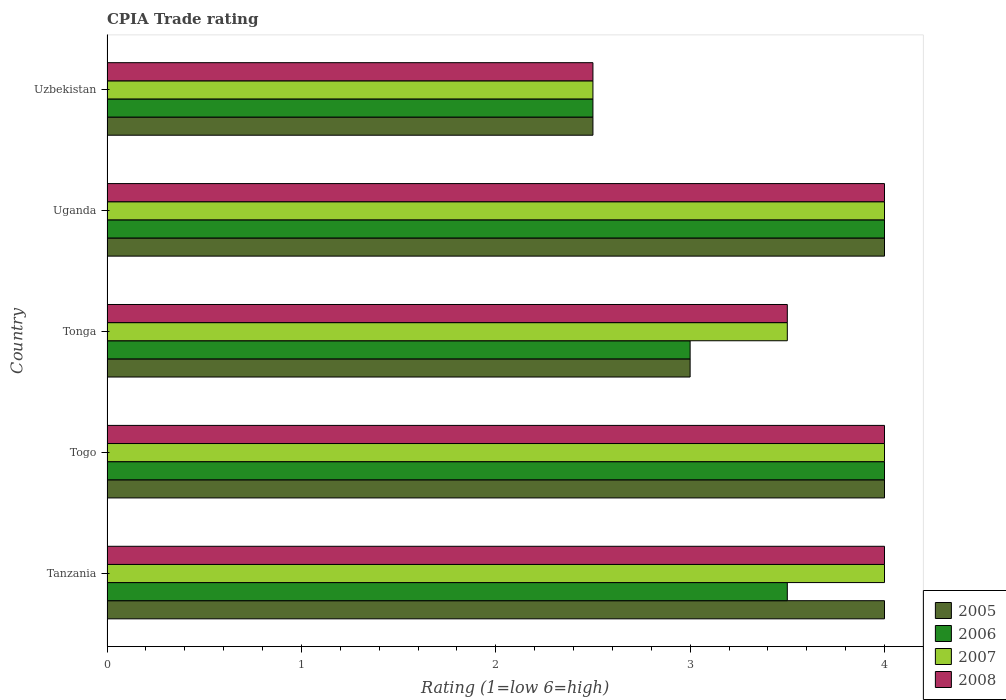How many different coloured bars are there?
Make the answer very short. 4. How many bars are there on the 3rd tick from the bottom?
Your response must be concise. 4. What is the label of the 4th group of bars from the top?
Provide a short and direct response. Togo. In how many cases, is the number of bars for a given country not equal to the number of legend labels?
Offer a terse response. 0. What is the CPIA rating in 2006 in Uganda?
Provide a succinct answer. 4. In which country was the CPIA rating in 2006 maximum?
Your answer should be compact. Togo. In which country was the CPIA rating in 2008 minimum?
Offer a terse response. Uzbekistan. What is the total CPIA rating in 2008 in the graph?
Keep it short and to the point. 18. What is the difference between the CPIA rating in 2005 in Tanzania and that in Uzbekistan?
Give a very brief answer. 1.5. What is the difference between the CPIA rating in 2006 in Uzbekistan and the CPIA rating in 2008 in Tonga?
Provide a short and direct response. -1. What is the average CPIA rating in 2005 per country?
Your answer should be very brief. 3.5. What is the difference between the CPIA rating in 2008 and CPIA rating in 2005 in Tonga?
Provide a succinct answer. 0.5. In how many countries, is the CPIA rating in 2008 greater than the average CPIA rating in 2008 taken over all countries?
Offer a very short reply. 3. Is it the case that in every country, the sum of the CPIA rating in 2006 and CPIA rating in 2008 is greater than the sum of CPIA rating in 2007 and CPIA rating in 2005?
Provide a succinct answer. No. Are all the bars in the graph horizontal?
Keep it short and to the point. Yes. How many countries are there in the graph?
Your answer should be compact. 5. Are the values on the major ticks of X-axis written in scientific E-notation?
Ensure brevity in your answer.  No. Does the graph contain any zero values?
Offer a terse response. No. How many legend labels are there?
Offer a terse response. 4. How are the legend labels stacked?
Your answer should be very brief. Vertical. What is the title of the graph?
Keep it short and to the point. CPIA Trade rating. Does "2013" appear as one of the legend labels in the graph?
Provide a short and direct response. No. What is the label or title of the X-axis?
Your answer should be very brief. Rating (1=low 6=high). What is the Rating (1=low 6=high) in 2005 in Tanzania?
Provide a succinct answer. 4. What is the Rating (1=low 6=high) in 2006 in Tanzania?
Ensure brevity in your answer.  3.5. What is the Rating (1=low 6=high) of 2008 in Togo?
Make the answer very short. 4. What is the Rating (1=low 6=high) in 2005 in Tonga?
Your answer should be very brief. 3. What is the Rating (1=low 6=high) in 2006 in Tonga?
Make the answer very short. 3. What is the Rating (1=low 6=high) in 2007 in Tonga?
Give a very brief answer. 3.5. What is the Rating (1=low 6=high) in 2008 in Tonga?
Provide a short and direct response. 3.5. What is the Rating (1=low 6=high) of 2007 in Uganda?
Make the answer very short. 4. What is the Rating (1=low 6=high) of 2008 in Uganda?
Keep it short and to the point. 4. What is the Rating (1=low 6=high) in 2007 in Uzbekistan?
Ensure brevity in your answer.  2.5. Across all countries, what is the maximum Rating (1=low 6=high) in 2007?
Your answer should be compact. 4. Across all countries, what is the minimum Rating (1=low 6=high) in 2005?
Offer a very short reply. 2.5. Across all countries, what is the minimum Rating (1=low 6=high) in 2007?
Offer a very short reply. 2.5. What is the total Rating (1=low 6=high) in 2006 in the graph?
Your response must be concise. 17. What is the total Rating (1=low 6=high) in 2007 in the graph?
Give a very brief answer. 18. What is the total Rating (1=low 6=high) of 2008 in the graph?
Offer a very short reply. 18. What is the difference between the Rating (1=low 6=high) of 2005 in Tanzania and that in Togo?
Your answer should be compact. 0. What is the difference between the Rating (1=low 6=high) of 2006 in Tanzania and that in Togo?
Make the answer very short. -0.5. What is the difference between the Rating (1=low 6=high) in 2006 in Tanzania and that in Tonga?
Give a very brief answer. 0.5. What is the difference between the Rating (1=low 6=high) in 2005 in Tanzania and that in Uganda?
Offer a terse response. 0. What is the difference between the Rating (1=low 6=high) of 2006 in Tanzania and that in Uganda?
Provide a succinct answer. -0.5. What is the difference between the Rating (1=low 6=high) in 2008 in Tanzania and that in Uganda?
Your response must be concise. 0. What is the difference between the Rating (1=low 6=high) in 2005 in Tanzania and that in Uzbekistan?
Ensure brevity in your answer.  1.5. What is the difference between the Rating (1=low 6=high) in 2007 in Tanzania and that in Uzbekistan?
Provide a succinct answer. 1.5. What is the difference between the Rating (1=low 6=high) of 2006 in Togo and that in Tonga?
Provide a short and direct response. 1. What is the difference between the Rating (1=low 6=high) of 2007 in Togo and that in Tonga?
Provide a short and direct response. 0.5. What is the difference between the Rating (1=low 6=high) of 2008 in Togo and that in Tonga?
Offer a terse response. 0.5. What is the difference between the Rating (1=low 6=high) of 2007 in Togo and that in Uganda?
Your response must be concise. 0. What is the difference between the Rating (1=low 6=high) of 2008 in Togo and that in Uganda?
Provide a succinct answer. 0. What is the difference between the Rating (1=low 6=high) in 2007 in Togo and that in Uzbekistan?
Your answer should be compact. 1.5. What is the difference between the Rating (1=low 6=high) of 2008 in Togo and that in Uzbekistan?
Keep it short and to the point. 1.5. What is the difference between the Rating (1=low 6=high) in 2006 in Tonga and that in Uganda?
Give a very brief answer. -1. What is the difference between the Rating (1=low 6=high) of 2007 in Tonga and that in Uganda?
Provide a succinct answer. -0.5. What is the difference between the Rating (1=low 6=high) of 2008 in Tonga and that in Uganda?
Keep it short and to the point. -0.5. What is the difference between the Rating (1=low 6=high) of 2005 in Tonga and that in Uzbekistan?
Give a very brief answer. 0.5. What is the difference between the Rating (1=low 6=high) of 2007 in Tonga and that in Uzbekistan?
Your response must be concise. 1. What is the difference between the Rating (1=low 6=high) of 2005 in Uganda and that in Uzbekistan?
Provide a short and direct response. 1.5. What is the difference between the Rating (1=low 6=high) of 2006 in Uganda and that in Uzbekistan?
Keep it short and to the point. 1.5. What is the difference between the Rating (1=low 6=high) in 2007 in Uganda and that in Uzbekistan?
Your response must be concise. 1.5. What is the difference between the Rating (1=low 6=high) of 2005 in Tanzania and the Rating (1=low 6=high) of 2006 in Togo?
Offer a very short reply. 0. What is the difference between the Rating (1=low 6=high) of 2005 in Tanzania and the Rating (1=low 6=high) of 2008 in Togo?
Your response must be concise. 0. What is the difference between the Rating (1=low 6=high) in 2006 in Tanzania and the Rating (1=low 6=high) in 2007 in Togo?
Provide a succinct answer. -0.5. What is the difference between the Rating (1=low 6=high) of 2005 in Tanzania and the Rating (1=low 6=high) of 2006 in Tonga?
Give a very brief answer. 1. What is the difference between the Rating (1=low 6=high) of 2005 in Tanzania and the Rating (1=low 6=high) of 2007 in Tonga?
Your answer should be very brief. 0.5. What is the difference between the Rating (1=low 6=high) of 2005 in Tanzania and the Rating (1=low 6=high) of 2008 in Tonga?
Your answer should be compact. 0.5. What is the difference between the Rating (1=low 6=high) of 2006 in Tanzania and the Rating (1=low 6=high) of 2007 in Tonga?
Your response must be concise. 0. What is the difference between the Rating (1=low 6=high) of 2006 in Tanzania and the Rating (1=low 6=high) of 2008 in Tonga?
Offer a very short reply. 0. What is the difference between the Rating (1=low 6=high) of 2007 in Tanzania and the Rating (1=low 6=high) of 2008 in Tonga?
Your response must be concise. 0.5. What is the difference between the Rating (1=low 6=high) in 2005 in Tanzania and the Rating (1=low 6=high) in 2006 in Uganda?
Give a very brief answer. 0. What is the difference between the Rating (1=low 6=high) of 2005 in Tanzania and the Rating (1=low 6=high) of 2008 in Uganda?
Ensure brevity in your answer.  0. What is the difference between the Rating (1=low 6=high) of 2006 in Tanzania and the Rating (1=low 6=high) of 2007 in Uganda?
Ensure brevity in your answer.  -0.5. What is the difference between the Rating (1=low 6=high) of 2006 in Tanzania and the Rating (1=low 6=high) of 2008 in Uganda?
Make the answer very short. -0.5. What is the difference between the Rating (1=low 6=high) in 2007 in Tanzania and the Rating (1=low 6=high) in 2008 in Uganda?
Keep it short and to the point. 0. What is the difference between the Rating (1=low 6=high) in 2007 in Tanzania and the Rating (1=low 6=high) in 2008 in Uzbekistan?
Your response must be concise. 1.5. What is the difference between the Rating (1=low 6=high) of 2005 in Togo and the Rating (1=low 6=high) of 2008 in Tonga?
Ensure brevity in your answer.  0.5. What is the difference between the Rating (1=low 6=high) in 2006 in Togo and the Rating (1=low 6=high) in 2007 in Tonga?
Your answer should be compact. 0.5. What is the difference between the Rating (1=low 6=high) of 2007 in Togo and the Rating (1=low 6=high) of 2008 in Tonga?
Make the answer very short. 0.5. What is the difference between the Rating (1=low 6=high) of 2005 in Togo and the Rating (1=low 6=high) of 2006 in Uzbekistan?
Ensure brevity in your answer.  1.5. What is the difference between the Rating (1=low 6=high) in 2005 in Togo and the Rating (1=low 6=high) in 2008 in Uzbekistan?
Your answer should be very brief. 1.5. What is the difference between the Rating (1=low 6=high) of 2006 in Togo and the Rating (1=low 6=high) of 2007 in Uzbekistan?
Your answer should be very brief. 1.5. What is the difference between the Rating (1=low 6=high) of 2007 in Togo and the Rating (1=low 6=high) of 2008 in Uzbekistan?
Keep it short and to the point. 1.5. What is the difference between the Rating (1=low 6=high) in 2005 in Tonga and the Rating (1=low 6=high) in 2006 in Uganda?
Offer a terse response. -1. What is the difference between the Rating (1=low 6=high) of 2005 in Tonga and the Rating (1=low 6=high) of 2008 in Uganda?
Provide a succinct answer. -1. What is the difference between the Rating (1=low 6=high) of 2005 in Tonga and the Rating (1=low 6=high) of 2007 in Uzbekistan?
Keep it short and to the point. 0.5. What is the difference between the Rating (1=low 6=high) in 2005 in Tonga and the Rating (1=low 6=high) in 2008 in Uzbekistan?
Make the answer very short. 0.5. What is the difference between the Rating (1=low 6=high) in 2006 in Tonga and the Rating (1=low 6=high) in 2007 in Uzbekistan?
Make the answer very short. 0.5. What is the difference between the Rating (1=low 6=high) in 2006 in Tonga and the Rating (1=low 6=high) in 2008 in Uzbekistan?
Offer a very short reply. 0.5. What is the difference between the Rating (1=low 6=high) of 2007 in Tonga and the Rating (1=low 6=high) of 2008 in Uzbekistan?
Ensure brevity in your answer.  1. What is the difference between the Rating (1=low 6=high) of 2005 in Uganda and the Rating (1=low 6=high) of 2008 in Uzbekistan?
Ensure brevity in your answer.  1.5. What is the difference between the Rating (1=low 6=high) in 2006 in Uganda and the Rating (1=low 6=high) in 2007 in Uzbekistan?
Offer a terse response. 1.5. What is the difference between the Rating (1=low 6=high) in 2006 in Uganda and the Rating (1=low 6=high) in 2008 in Uzbekistan?
Offer a terse response. 1.5. What is the average Rating (1=low 6=high) in 2005 per country?
Make the answer very short. 3.5. What is the average Rating (1=low 6=high) of 2007 per country?
Provide a short and direct response. 3.6. What is the average Rating (1=low 6=high) of 2008 per country?
Make the answer very short. 3.6. What is the difference between the Rating (1=low 6=high) in 2005 and Rating (1=low 6=high) in 2007 in Tanzania?
Ensure brevity in your answer.  0. What is the difference between the Rating (1=low 6=high) of 2005 and Rating (1=low 6=high) of 2008 in Tanzania?
Ensure brevity in your answer.  0. What is the difference between the Rating (1=low 6=high) of 2006 and Rating (1=low 6=high) of 2008 in Tanzania?
Give a very brief answer. -0.5. What is the difference between the Rating (1=low 6=high) in 2007 and Rating (1=low 6=high) in 2008 in Tanzania?
Offer a terse response. 0. What is the difference between the Rating (1=low 6=high) of 2005 and Rating (1=low 6=high) of 2006 in Togo?
Make the answer very short. 0. What is the difference between the Rating (1=low 6=high) of 2005 and Rating (1=low 6=high) of 2007 in Togo?
Provide a succinct answer. 0. What is the difference between the Rating (1=low 6=high) of 2005 and Rating (1=low 6=high) of 2008 in Togo?
Provide a short and direct response. 0. What is the difference between the Rating (1=low 6=high) in 2006 and Rating (1=low 6=high) in 2007 in Togo?
Provide a short and direct response. 0. What is the difference between the Rating (1=low 6=high) of 2006 and Rating (1=low 6=high) of 2008 in Togo?
Give a very brief answer. 0. What is the difference between the Rating (1=low 6=high) of 2007 and Rating (1=low 6=high) of 2008 in Togo?
Your response must be concise. 0. What is the difference between the Rating (1=low 6=high) of 2005 and Rating (1=low 6=high) of 2006 in Tonga?
Your answer should be very brief. 0. What is the difference between the Rating (1=low 6=high) of 2005 and Rating (1=low 6=high) of 2007 in Tonga?
Offer a terse response. -0.5. What is the difference between the Rating (1=low 6=high) in 2006 and Rating (1=low 6=high) in 2008 in Tonga?
Offer a terse response. -0.5. What is the difference between the Rating (1=low 6=high) in 2005 and Rating (1=low 6=high) in 2006 in Uganda?
Your answer should be very brief. 0. What is the difference between the Rating (1=low 6=high) of 2005 and Rating (1=low 6=high) of 2007 in Uganda?
Ensure brevity in your answer.  0. What is the difference between the Rating (1=low 6=high) of 2005 and Rating (1=low 6=high) of 2008 in Uganda?
Offer a very short reply. 0. What is the difference between the Rating (1=low 6=high) of 2006 and Rating (1=low 6=high) of 2007 in Uganda?
Make the answer very short. 0. What is the difference between the Rating (1=low 6=high) of 2006 and Rating (1=low 6=high) of 2008 in Uganda?
Your answer should be compact. 0. What is the difference between the Rating (1=low 6=high) of 2007 and Rating (1=low 6=high) of 2008 in Uganda?
Keep it short and to the point. 0. What is the difference between the Rating (1=low 6=high) in 2005 and Rating (1=low 6=high) in 2008 in Uzbekistan?
Make the answer very short. 0. What is the difference between the Rating (1=low 6=high) in 2006 and Rating (1=low 6=high) in 2007 in Uzbekistan?
Your answer should be compact. 0. What is the difference between the Rating (1=low 6=high) in 2006 and Rating (1=low 6=high) in 2008 in Uzbekistan?
Your response must be concise. 0. What is the ratio of the Rating (1=low 6=high) of 2006 in Tanzania to that in Togo?
Offer a very short reply. 0.88. What is the ratio of the Rating (1=low 6=high) in 2008 in Tanzania to that in Togo?
Ensure brevity in your answer.  1. What is the ratio of the Rating (1=low 6=high) in 2006 in Tanzania to that in Tonga?
Offer a very short reply. 1.17. What is the ratio of the Rating (1=low 6=high) of 2008 in Tanzania to that in Tonga?
Ensure brevity in your answer.  1.14. What is the ratio of the Rating (1=low 6=high) in 2005 in Tanzania to that in Uzbekistan?
Your response must be concise. 1.6. What is the ratio of the Rating (1=low 6=high) of 2005 in Togo to that in Tonga?
Make the answer very short. 1.33. What is the ratio of the Rating (1=low 6=high) of 2006 in Togo to that in Tonga?
Your answer should be compact. 1.33. What is the ratio of the Rating (1=low 6=high) of 2008 in Togo to that in Tonga?
Your response must be concise. 1.14. What is the ratio of the Rating (1=low 6=high) in 2006 in Togo to that in Uganda?
Offer a very short reply. 1. What is the ratio of the Rating (1=low 6=high) of 2005 in Togo to that in Uzbekistan?
Your response must be concise. 1.6. What is the ratio of the Rating (1=low 6=high) in 2005 in Tonga to that in Uganda?
Provide a short and direct response. 0.75. What is the ratio of the Rating (1=low 6=high) in 2006 in Tonga to that in Uganda?
Ensure brevity in your answer.  0.75. What is the ratio of the Rating (1=low 6=high) of 2008 in Tonga to that in Uganda?
Your answer should be very brief. 0.88. What is the ratio of the Rating (1=low 6=high) of 2006 in Tonga to that in Uzbekistan?
Provide a short and direct response. 1.2. What is the ratio of the Rating (1=low 6=high) in 2008 in Tonga to that in Uzbekistan?
Give a very brief answer. 1.4. What is the ratio of the Rating (1=low 6=high) of 2006 in Uganda to that in Uzbekistan?
Keep it short and to the point. 1.6. 